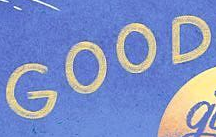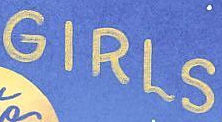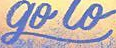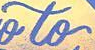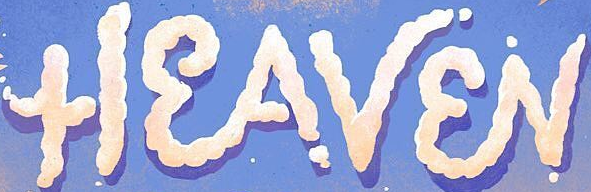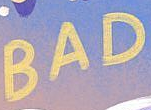Read the text content from these images in order, separated by a semicolon. GOOD; GIRLS; go; to; HEAVEN; BAD 